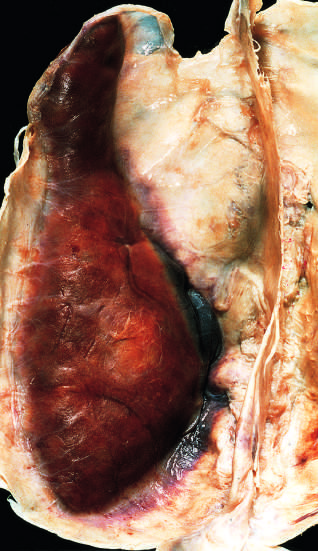what is large organizing subdural hematoma attached to?
Answer the question using a single word or phrase. The dura 